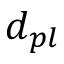Convert formula to latex. <formula><loc_0><loc_0><loc_500><loc_500>d _ { p l }</formula> 